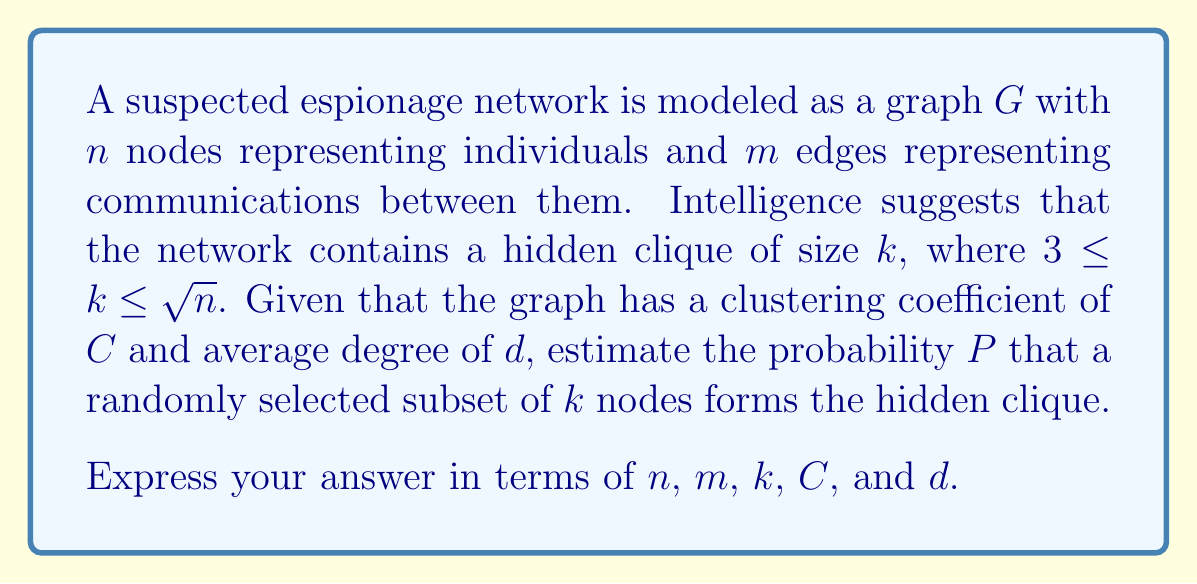Solve this math problem. To solve this problem, we need to consider the topology of the communication network and use concepts from graph theory and probability. Let's break it down step-by-step:

1) First, recall that the clustering coefficient $C$ is the probability that two neighbors of a node are also connected. In a clique, all nodes are connected to each other, so the local clustering coefficient for each node in the clique is 1.

2) The total number of possible subsets of $k$ nodes in a graph with $n$ nodes is $\binom{n}{k}$.

3) The number of edges in a clique of size $k$ is $\binom{k}{2} = \frac{k(k-1)}{2}$.

4) The probability that a randomly selected edge exists in the graph is approximately $\frac{m}{\binom{n}{2}}$, assuming the graph is not too dense.

5) For a subset of $k$ nodes to form a clique, all $\binom{k}{2}$ edges must exist between them. The probability of this happening randomly is:

   $$P(\text{clique}) \approx \left(\frac{m}{\binom{n}{2}}\right)^{\binom{k}{2}}$$

6) However, we know that the graph has a clustering coefficient of $C$, which increases the likelihood of finding a clique. We can adjust our probability by factoring in $C$:

   $$P(\text{clique}) \approx C \cdot \left(\frac{m}{\binom{n}{2}}\right)^{\binom{k}{2}}$$

7) The average degree $d$ also provides information about the density of the graph. We can use it to refine our estimate:

   $$P(\text{clique}) \approx C \cdot \left(\frac{d}{n-1}\right)^{\binom{k}{2}}$$

8) Finally, we need to consider that there are $\binom{n}{k}$ possible subsets of size $k$. The probability that at least one of these subsets forms the hidden clique is:

   $$P = 1 - (1 - P(\text{clique}))^{\binom{n}{k}}$$

Substituting our expression for $P(\text{clique})$, we get our final formula.
Answer: $$P \approx 1 - \left(1 - C \cdot \left(\frac{d}{n-1}\right)^{\frac{k(k-1)}{2}}\right)^{\binom{n}{k}}$$ 